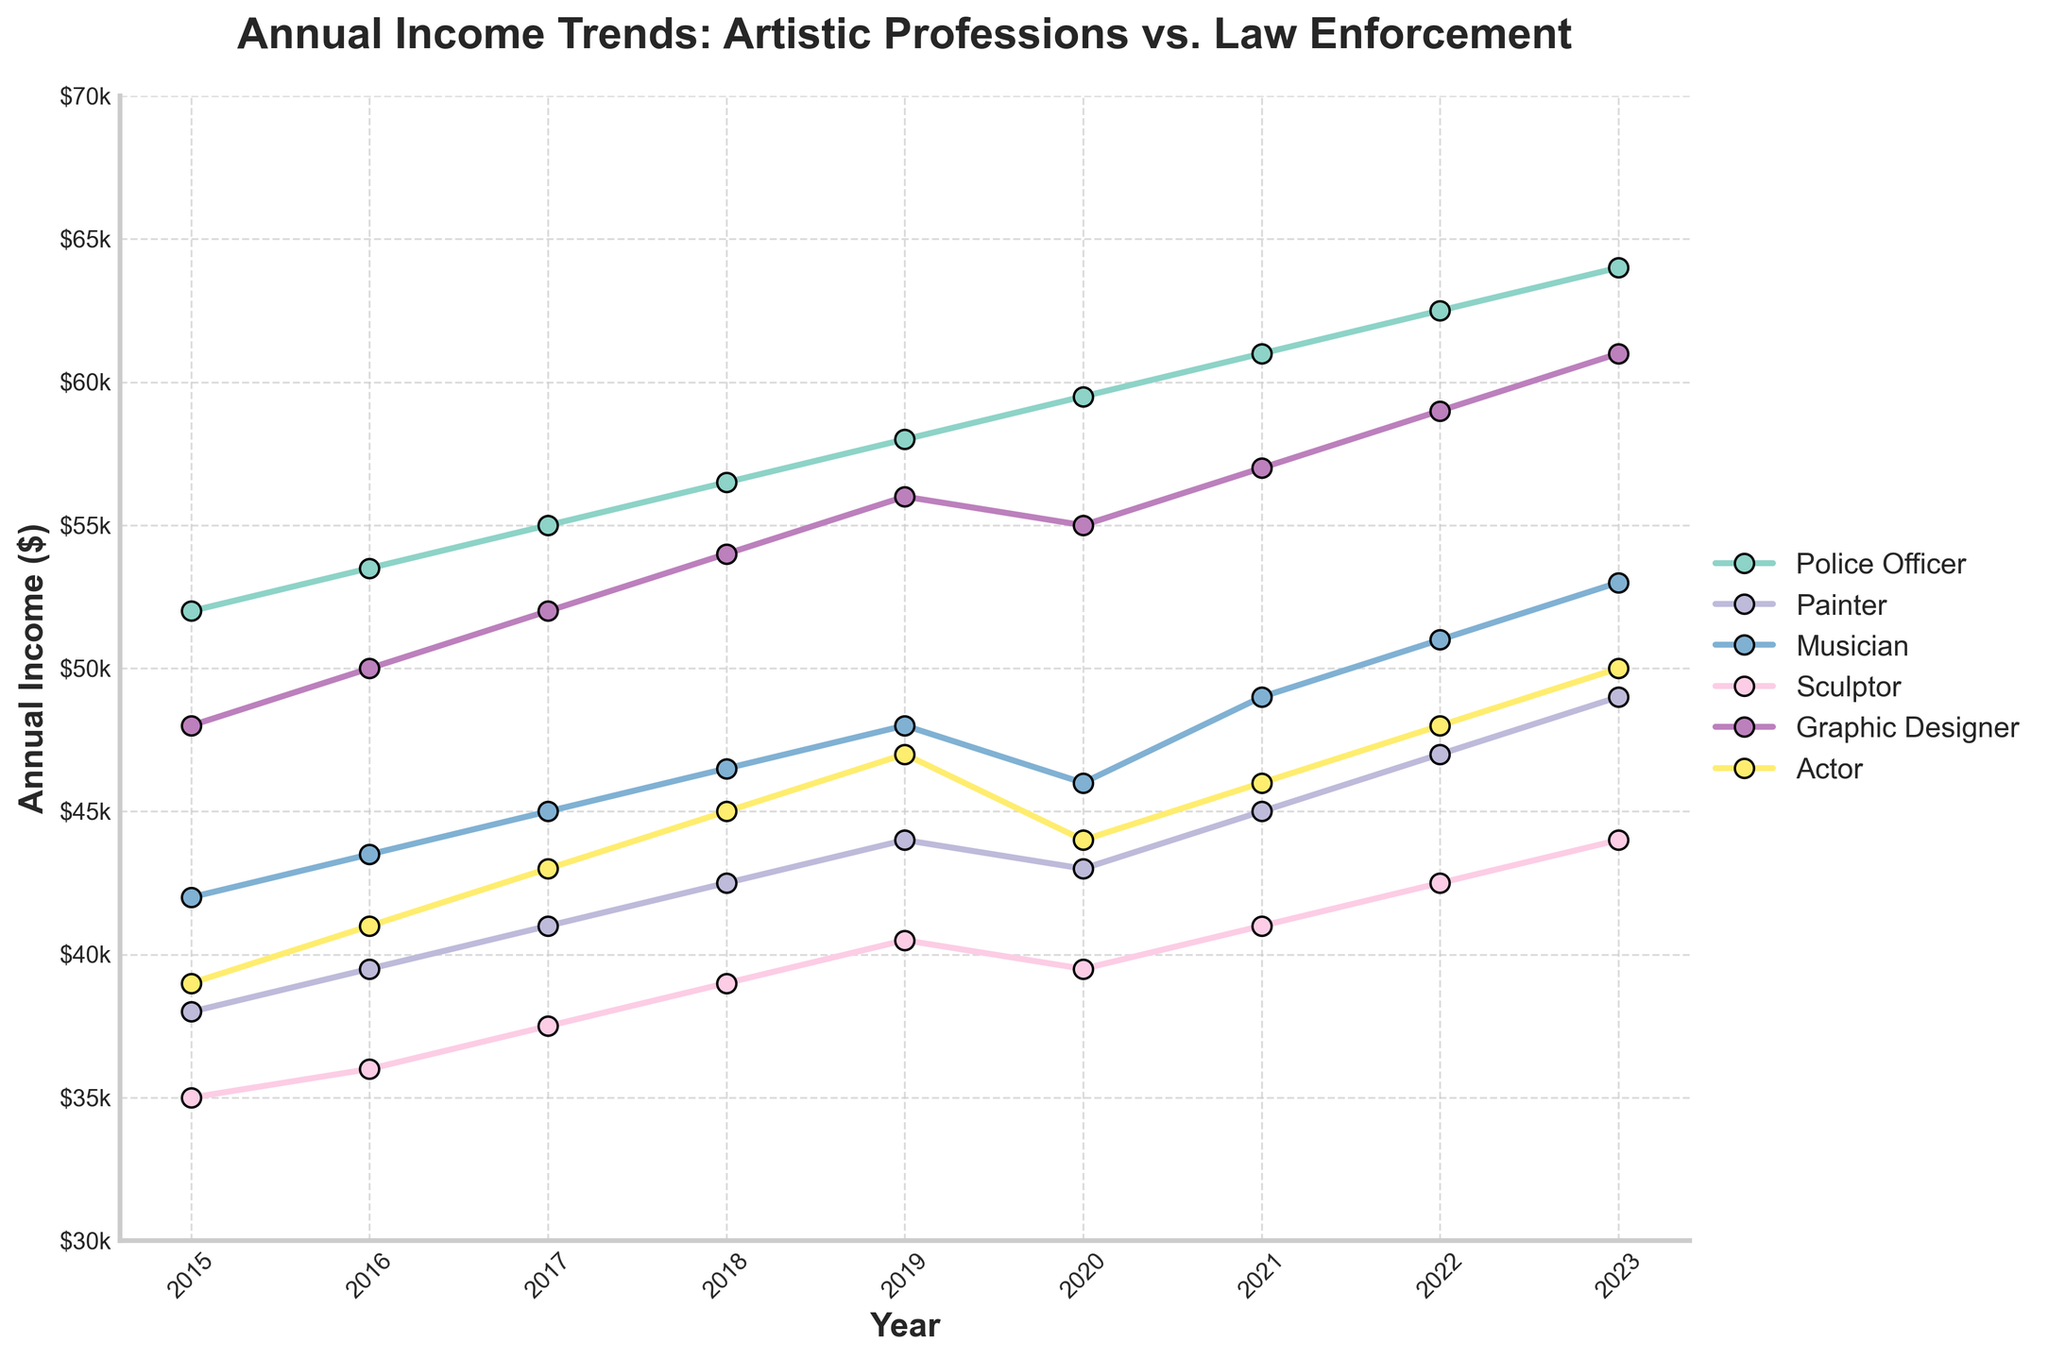What's the average annual income for a painter between 2015 and 2023? To find the average, sum all the given annual incomes for the painter from 2015 to 2023 and then divide by the number of years. (38000 + 39500 + 41000 + 42500 + 44000 + 43000 + 45000 + 47000 + 49000) / 9
Answer: 43222.22 Which profession had the highest annual income in 2023? Look at the figure for the year 2023 and identify the highest point among all the professions. The graphic designer reached $61,000, which is the highest.
Answer: Graphic Designer Did the annual income of musicians ever surpass that of police officers? Compare the line trends of musicians and police officers throughout the years from 2015 to 2023. The police officer's line is always above the musician's line, showing it never surpassed.
Answer: No Which profession had the smallest increase in annual income from 2015 to 2023? Calculate the difference between 2023 and 2015 for each profession and find the smallest value. For sculptor: 44000-35000=9000. Painter: 49000-38000=11000. Musician: 53000-42000=11000. Graphic Designer: 61000-48000=13000. Actor: 50000-39000=11000. Sculptor has the smallest increase of $9000.
Answer: Sculptor What was the total income earned by a graphic designer from 2015 to 2023? Sum the incomes for a graphic designer over all the years from 2015 to 2023. (48000 + 50000 + 52000 + 54000 + 56000 + 55000 + 57000 + 59000 + 61000)
Answer: 483000 Between which two consecutive years did actors experience the largest income increase? Calculate the difference between each consecutive year for actors and find the maximum. 2016-2015: 41000-39000=2000. 2017-2016: 43000-41000=2000. 2018-2017: 45000-43000=2000. 2019-2018: 47000-45000=2000. 2021-2020: 46000-44000=2000. 2022-2021: 48000-46000=2000. All years had equal increases of $2000.
Answer: All years had $2000 increases How did the annual income of a graphic designer compare to that of a police officer in 2020? Check the values for 2020 for both professions. Graphic Designer: $55,000, Police Officer: $59,500. The police officer earned more.
Answer: Police Officer earned more Which profession had the steepest decline in annual income between any two years? Identify any instances of decline in annual income for each profession between consecutive years and find the steepest. Only musicians and actors declined. Musicians: 2020-2019 (46000-48000=-2000). Actors: 2020-2019 (44000-47000=-3000). Actor had the steepest decline of $3000 between 2019 and 2020.
Answer: Actor Between 2019 and 2023, which profession showed the most steady growth in annual income? Examine the line trends from 2019 to 2023 for all professions and identify the overly linear or consistent increases. The most steady without big jumps appears to be the Police Officer, with annual increases of $1500 each year.
Answer: Police Officer 